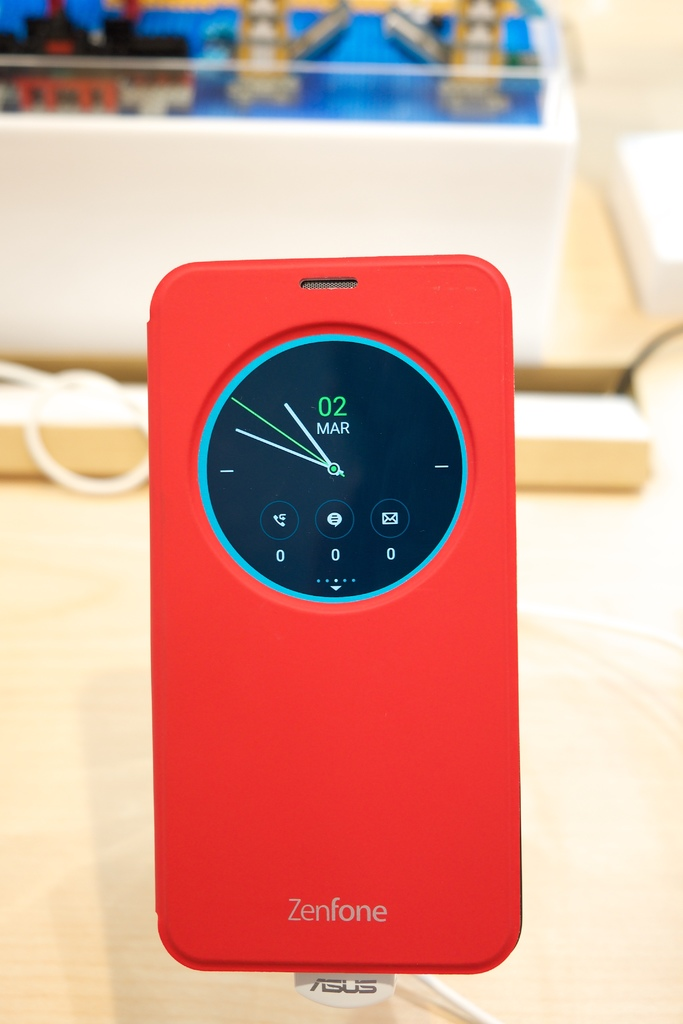What unique functionalities does the circular display on this Zenfone case provide? The circular display on the Zenfone case acts as an always-on screen, providing real-time updates like time, date, and notification icons without the need to wake the primary device's screen, enhancing battery efficiency and convenience. 